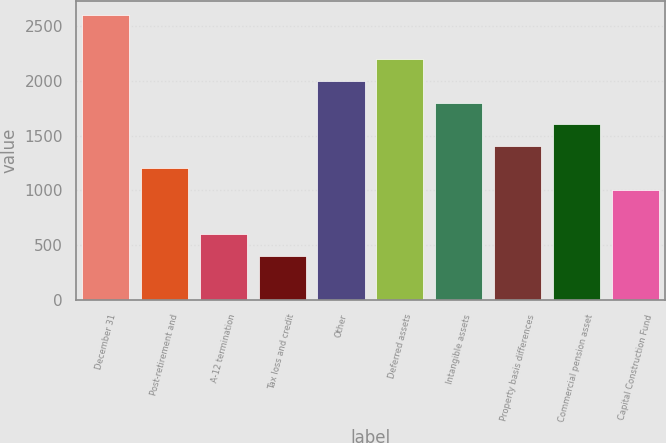Convert chart to OTSL. <chart><loc_0><loc_0><loc_500><loc_500><bar_chart><fcel>December 31<fcel>Post-retirement and<fcel>A-12 termination<fcel>Tax loss and credit<fcel>Other<fcel>Deferred assets<fcel>Intangible assets<fcel>Property basis differences<fcel>Commercial pension asset<fcel>Capital Construction Fund<nl><fcel>2603.6<fcel>1202.2<fcel>601.6<fcel>401.4<fcel>2003<fcel>2203.2<fcel>1802.8<fcel>1402.4<fcel>1602.6<fcel>1002<nl></chart> 